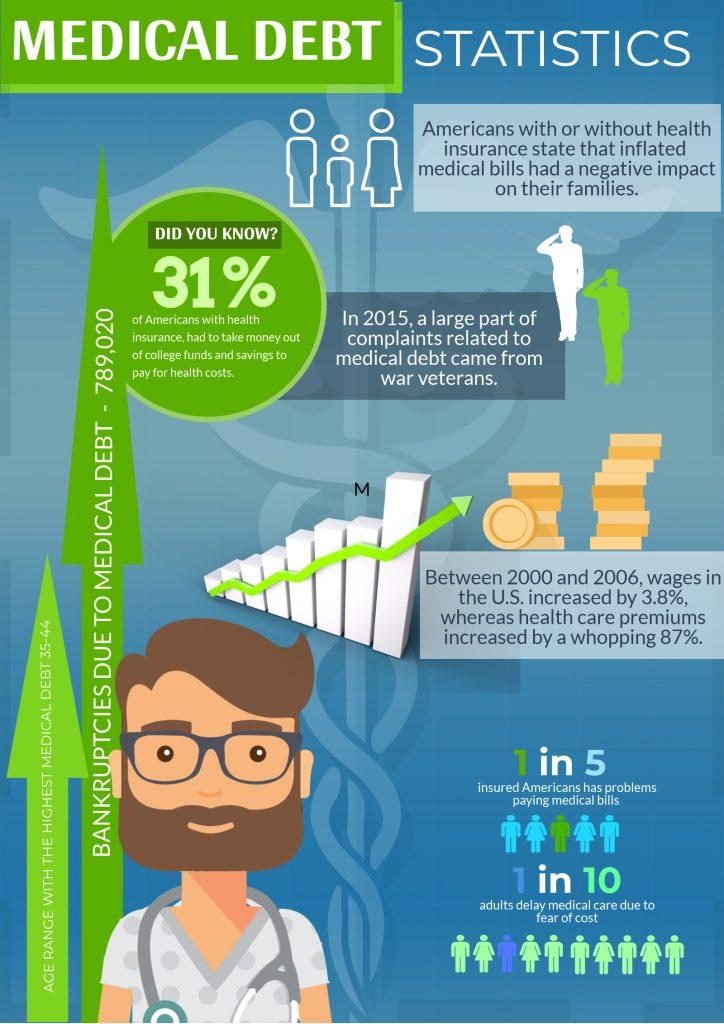Indicate a few pertinent items in this graphic. The letter 'M' is written in black above the green arrow. In the United States, it is estimated that up to 10% of individuals delay medical care due to cost, causing significant delays in treatment and potentially leading to poor health outcomes. According to recent statistics, approximately 20% of Americans are struggling with paying their medical bills. In addition to health insurance, other sources of funding to cover healthcare costs may include college funds and savings. In the past six years, the wage increase was 3.8%. 